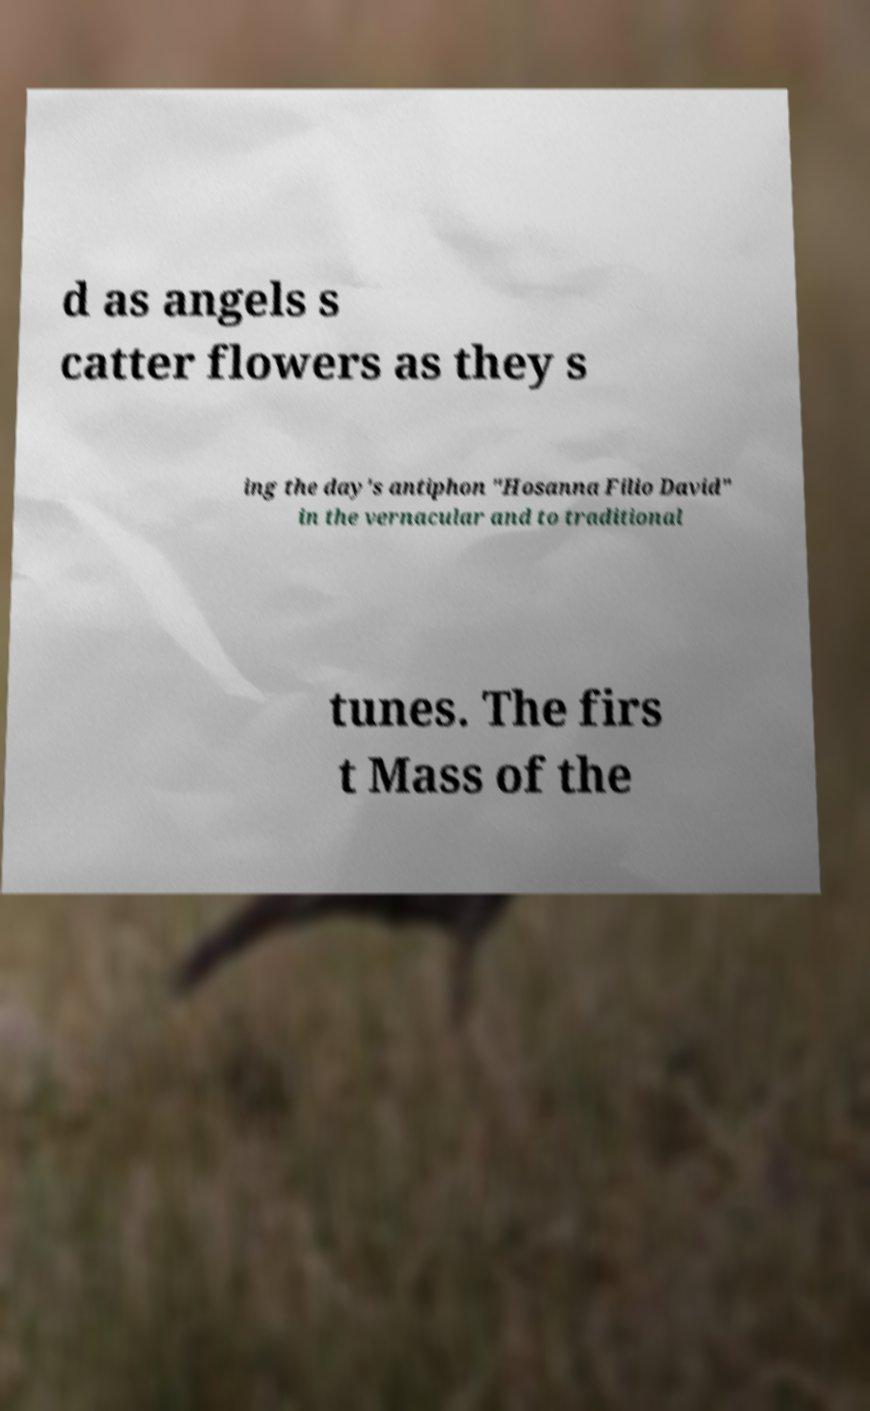Could you assist in decoding the text presented in this image and type it out clearly? d as angels s catter flowers as they s ing the day's antiphon "Hosanna Filio David" in the vernacular and to traditional tunes. The firs t Mass of the 